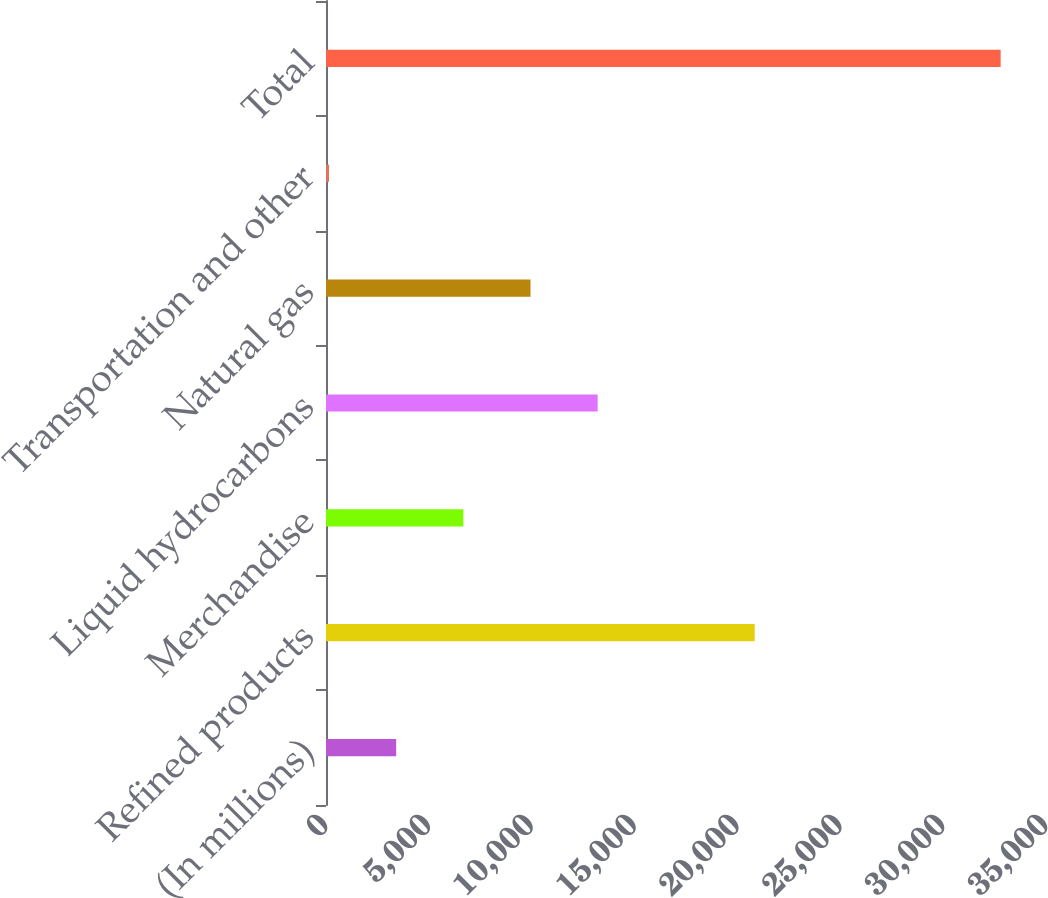Convert chart to OTSL. <chart><loc_0><loc_0><loc_500><loc_500><bar_chart><fcel>(In millions)<fcel>Refined products<fcel>Merchandise<fcel>Liquid hydrocarbons<fcel>Natural gas<fcel>Transportation and other<fcel>Total<nl><fcel>3411<fcel>20841<fcel>6676<fcel>13206<fcel>9941<fcel>146<fcel>32796<nl></chart> 